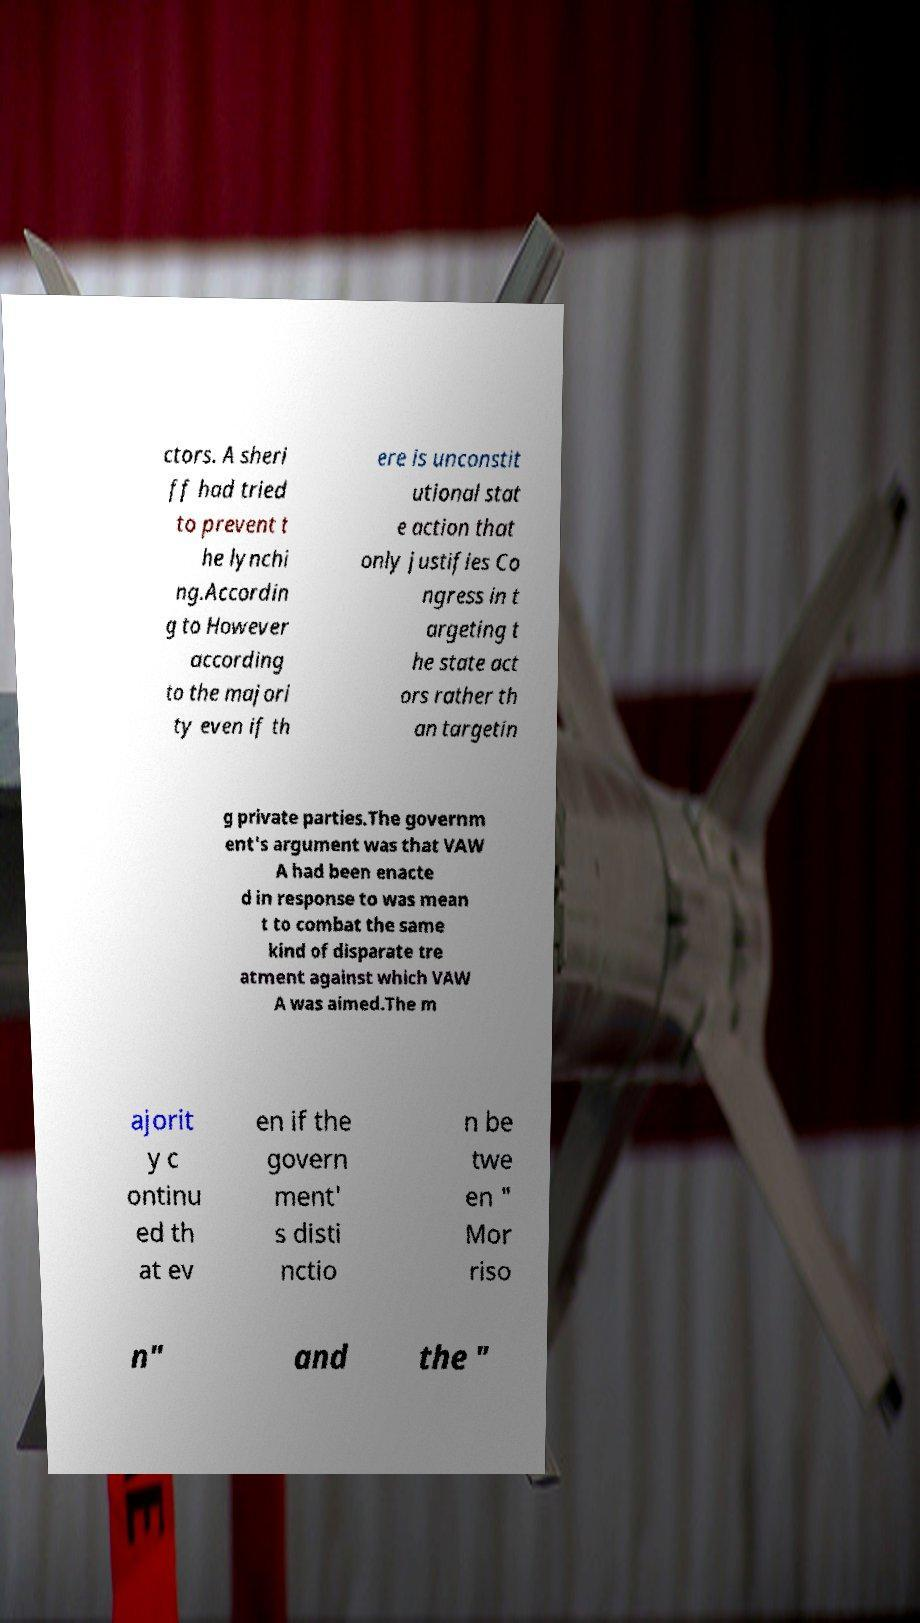What messages or text are displayed in this image? I need them in a readable, typed format. ctors. A sheri ff had tried to prevent t he lynchi ng.Accordin g to However according to the majori ty even if th ere is unconstit utional stat e action that only justifies Co ngress in t argeting t he state act ors rather th an targetin g private parties.The governm ent's argument was that VAW A had been enacte d in response to was mean t to combat the same kind of disparate tre atment against which VAW A was aimed.The m ajorit y c ontinu ed th at ev en if the govern ment' s disti nctio n be twe en " Mor riso n" and the " 